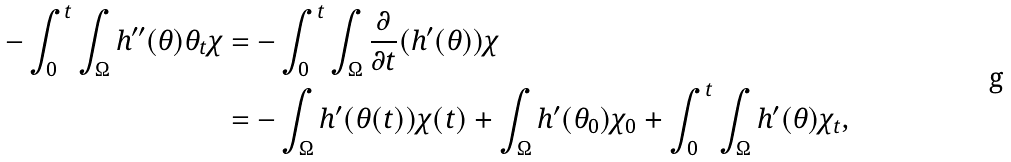Convert formula to latex. <formula><loc_0><loc_0><loc_500><loc_500>- \int _ { 0 } ^ { t } \int _ { \Omega } h ^ { \prime \prime } ( \theta ) \theta _ { t } \chi & = - \int _ { 0 } ^ { t } \int _ { \Omega } \frac { \partial } { \partial t } ( h ^ { \prime } ( \theta ) ) \chi \\ & = - \int _ { \Omega } h ^ { \prime } ( \theta ( t ) ) \chi ( t ) + \int _ { \Omega } h ^ { \prime } ( \theta _ { 0 } ) \chi _ { 0 } + \int _ { 0 } ^ { t } \int _ { \Omega } h ^ { \prime } ( \theta ) \chi _ { t } ,</formula> 